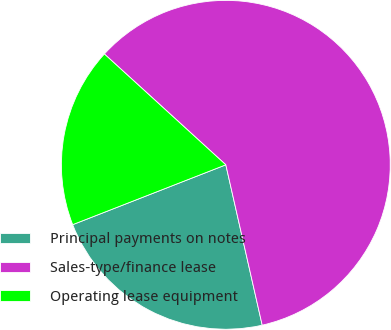Convert chart. <chart><loc_0><loc_0><loc_500><loc_500><pie_chart><fcel>Principal payments on notes<fcel>Sales-type/finance lease<fcel>Operating lease equipment<nl><fcel>22.62%<fcel>59.67%<fcel>17.7%<nl></chart> 